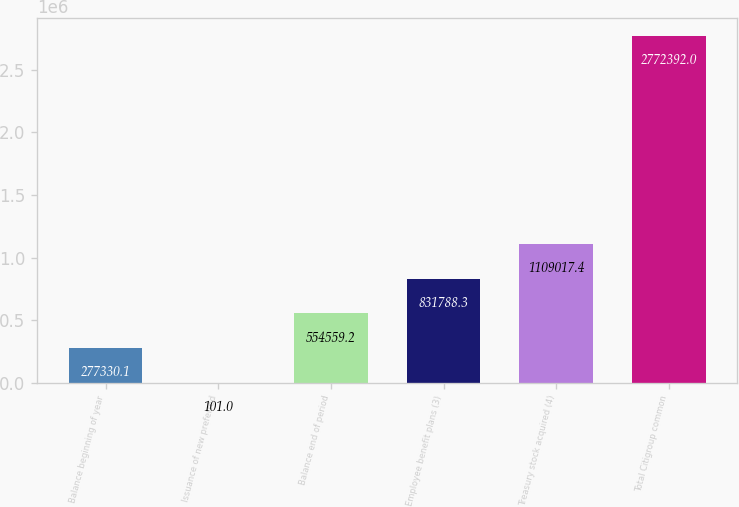<chart> <loc_0><loc_0><loc_500><loc_500><bar_chart><fcel>Balance beginning of year<fcel>Issuance of new preferred<fcel>Balance end of period<fcel>Employee benefit plans (3)<fcel>Treasury stock acquired (4)<fcel>Total Citigroup common<nl><fcel>277330<fcel>101<fcel>554559<fcel>831788<fcel>1.10902e+06<fcel>2.77239e+06<nl></chart> 